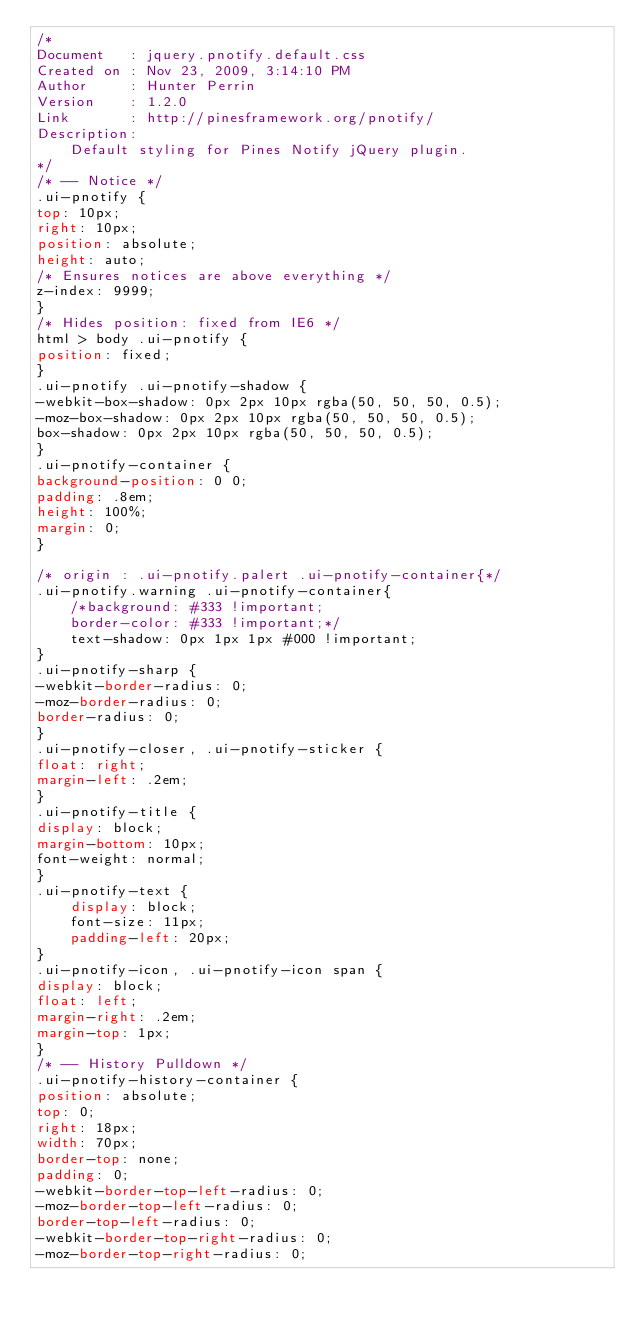Convert code to text. <code><loc_0><loc_0><loc_500><loc_500><_CSS_>/*
Document   : jquery.pnotify.default.css
Created on : Nov 23, 2009, 3:14:10 PM
Author     : Hunter Perrin
Version    : 1.2.0
Link       : http://pinesframework.org/pnotify/
Description:
	Default styling for Pines Notify jQuery plugin.
*/
/* -- Notice */
.ui-pnotify {
top: 10px;
right: 10px;
position: absolute;
height: auto;
/* Ensures notices are above everything */
z-index: 9999;
}
/* Hides position: fixed from IE6 */
html > body .ui-pnotify {
position: fixed;
}
.ui-pnotify .ui-pnotify-shadow {
-webkit-box-shadow: 0px 2px 10px rgba(50, 50, 50, 0.5);
-moz-box-shadow: 0px 2px 10px rgba(50, 50, 50, 0.5);
box-shadow: 0px 2px 10px rgba(50, 50, 50, 0.5);
}
.ui-pnotify-container {
background-position: 0 0;
padding: .8em;
height: 100%;
margin: 0;
}

/* origin : .ui-pnotify.palert .ui-pnotify-container{*/
.ui-pnotify.warning .ui-pnotify-container{
    /*background: #333 !important;
    border-color: #333 !important;*/
    text-shadow: 0px 1px 1px #000 !important;
}
.ui-pnotify-sharp {
-webkit-border-radius: 0;
-moz-border-radius: 0;
border-radius: 0;
}
.ui-pnotify-closer, .ui-pnotify-sticker {
float: right;
margin-left: .2em;
}
.ui-pnotify-title {
display: block;
margin-bottom: 10px;
font-weight: normal;
}
.ui-pnotify-text {
    display: block;
    font-size: 11px;
    padding-left: 20px;
}
.ui-pnotify-icon, .ui-pnotify-icon span {
display: block;
float: left;
margin-right: .2em;
margin-top: 1px;
}
/* -- History Pulldown */
.ui-pnotify-history-container {
position: absolute;
top: 0;
right: 18px;
width: 70px;
border-top: none;
padding: 0;
-webkit-border-top-left-radius: 0;
-moz-border-top-left-radius: 0;
border-top-left-radius: 0;
-webkit-border-top-right-radius: 0;
-moz-border-top-right-radius: 0;</code> 